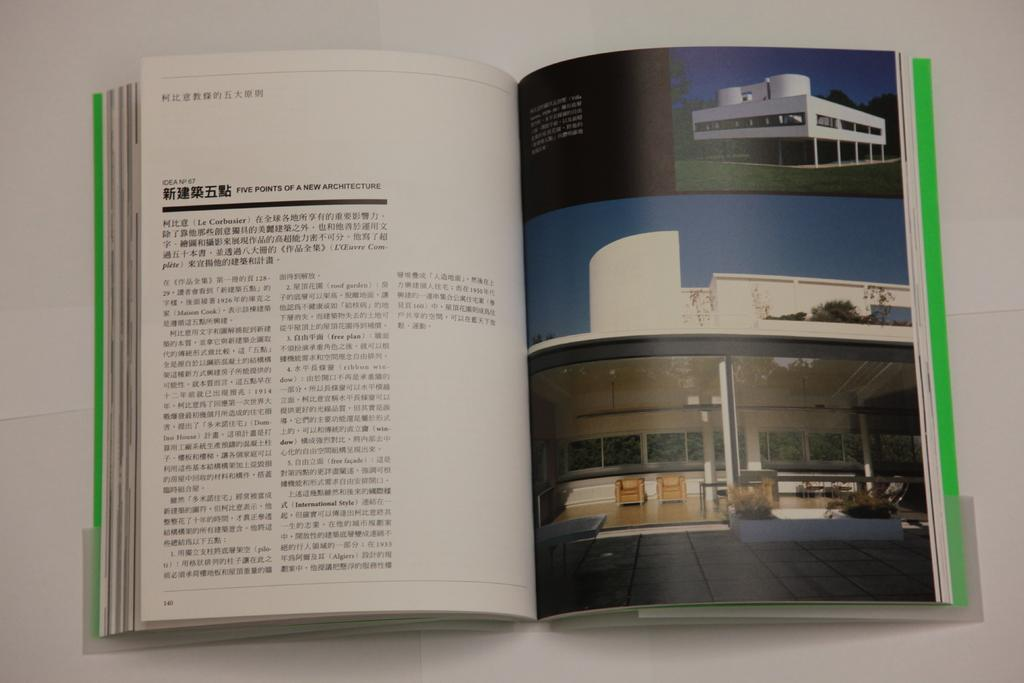Provide a one-sentence caption for the provided image. An architecture book is opened up to a page about the five points of a new architecture. 